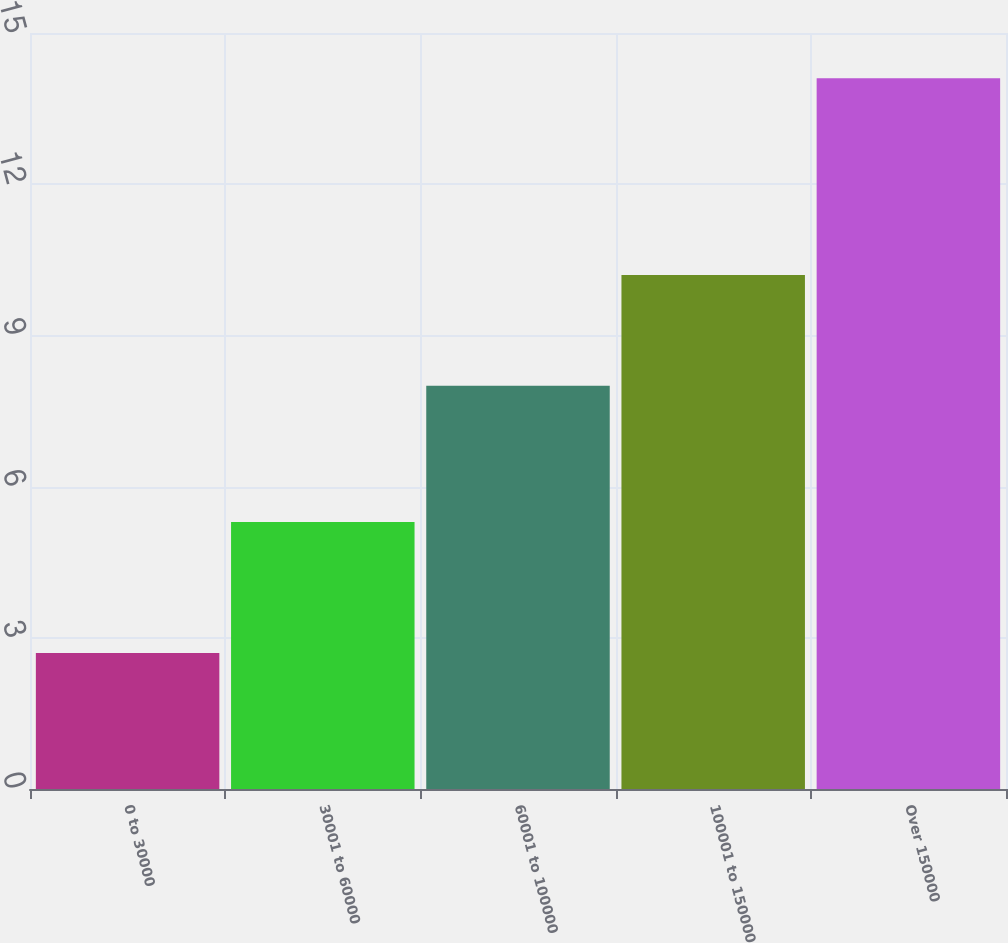Convert chart. <chart><loc_0><loc_0><loc_500><loc_500><bar_chart><fcel>0 to 30000<fcel>30001 to 60000<fcel>60001 to 100000<fcel>100001 to 150000<fcel>Over 150000<nl><fcel>2.7<fcel>5.3<fcel>8<fcel>10.2<fcel>14.1<nl></chart> 